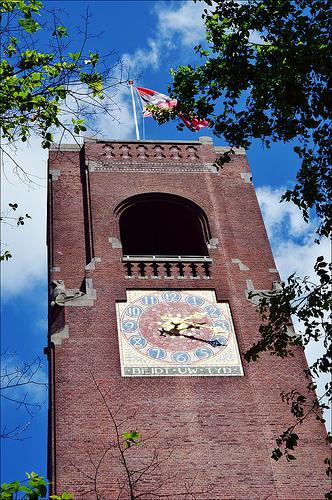Question: what time is it?
Choices:
A. 1:00.
B. 2:20.
C. 3:30.
D. 4:45.
Answer with the letter. Answer: B Question: who built the tower?
Choices:
A. Iron workers.
B. Carpenters.
C. Stone masons.
D. Men.
Answer with the letter. Answer: C Question: what is on top of the tower?
Choices:
A. Cross.
B. Flag.
C. Wind vane.
D. Bell.
Answer with the letter. Answer: B Question: where is the window?
Choices:
A. Beside the bed.
B. Above the clock.
C. Behind the table.
D. Above the sink.
Answer with the letter. Answer: B 